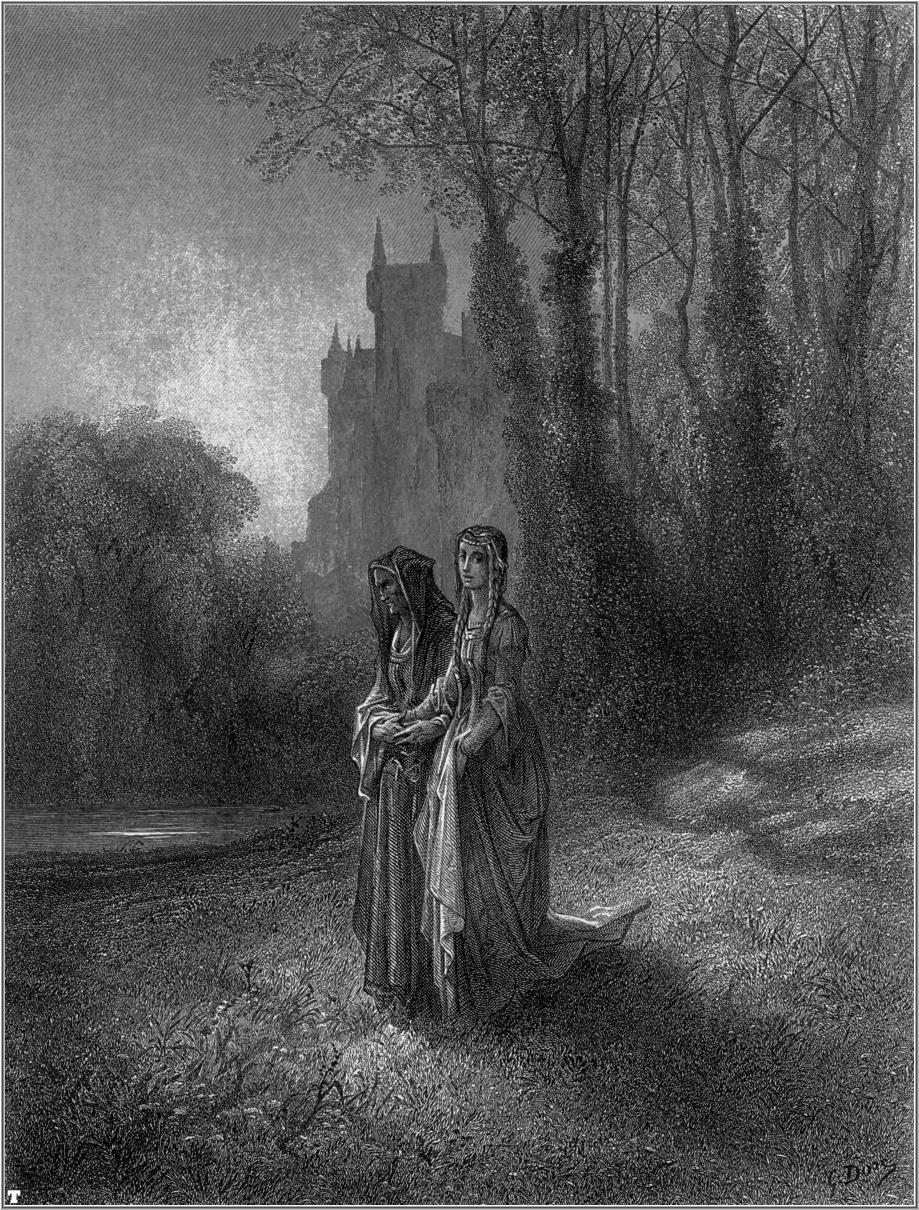In a realistic scenario, who might the women be and what era could the image represent? In a realistic scenario, the women could be nobility or high-born ladies from a medieval or Renaissance era. Their elaborate and elegant dresses suggest a status beyond that of common villagers, indicating they might be part of a noble family residing in the nearby castle. The scene could date back to between the 14th and 17th centuries, a period known for grand castles and formal attire. During this time, it was common for noblewomen to engage in walks through their estates, reflecting their connection to the land and their leisurely lifestyle while also allowing them to partake in the tranquility and natural beauty of their surroundings. 